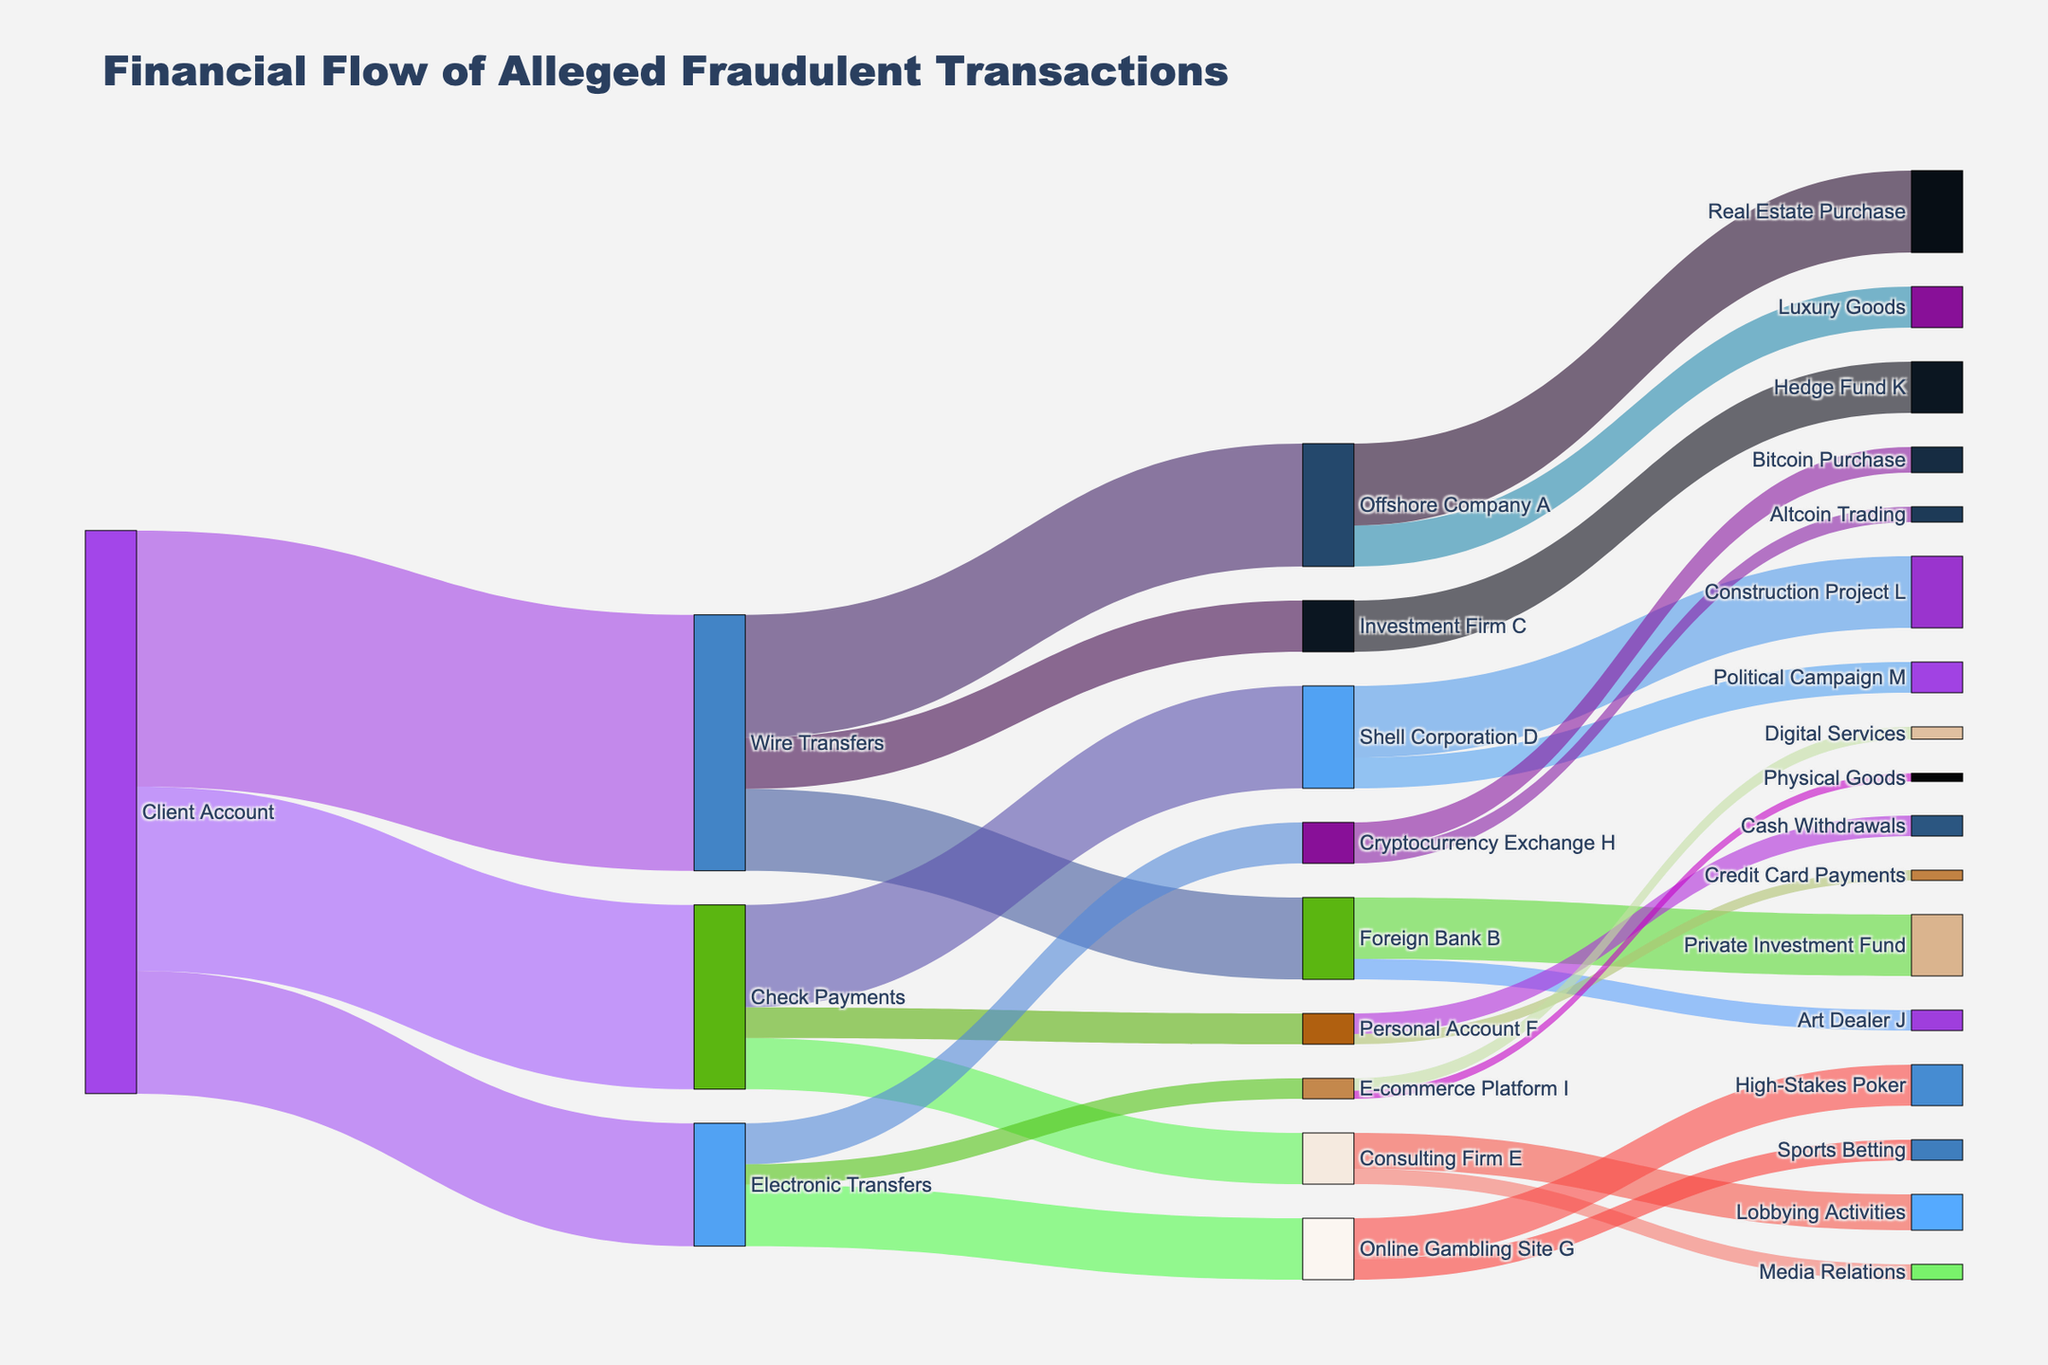What is the title of the figure? The title is placed at the top of the figure and clearly indicates its main focus by providing a summary of what the figure represents.
Answer: Financial Flow of Alleged Fraudulent Transactions How many types of transactions are there from the Client Account? Look at the nodes directly connected to the Client Account; each connecting node represents a different type of transaction.
Answer: Three (Wire Transfers, Check Payments, Electronic Transfers) Which recipient received the highest value from Wire Transfers? Identify the connections from Wire Transfers and compare their values. The recipient with the highest value is the one with the largest flow.
Answer: Offshore Company A Total value received by Foreign Bank B? Find all the flows entering Foreign Bank B and sum their values.
Answer: 800000 What is the total value that passed through Wire Transfers? Sum all the values flowing out of Wire Transfers by adding the values going to each recipient.
Answer: 2500000 Which transaction type directed funds to Political Campaign M? Trace the flow backward from Political Campaign M to find the origin transaction type.
Answer: Check Payments Compare the values received by Shell Corporation D and Consulting Firm E from Check Payments. Which one received more? Look at the flows from Check Payments to both Shell Corporation D and Consulting Firm E and compare their values.
Answer: Shell Corporation D (1000000 vs. 500000) Which recipient connected to Electronic Transfers dealt with physical goods? Identify the target node connected to Electronic Transfers that mentions physical goods as per its label.
Answer: E-commerce Platform I What is the sum of funds transferred for Lobbying Activities and Media Relations by Consulting Firm E? Sum the values directed from Consulting Firm E to Lobbying Activities and Media Relations.
Answer: 500000 From the breakdown, which node had the largest variety of subsequent transaction recipients? Compare the number of outgoing connections of each node to determine which has the most variety in terms of different recipients.
Answer: Wire Transfers 